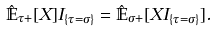<formula> <loc_0><loc_0><loc_500><loc_500>\hat { \mathbb { E } } _ { \tau + } [ X ] I _ { \{ \tau = \sigma \} } = \hat { \mathbb { E } } _ { \sigma + } [ X I _ { \{ \tau = \sigma \} } ] .</formula> 